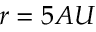<formula> <loc_0><loc_0><loc_500><loc_500>r = 5 A U</formula> 